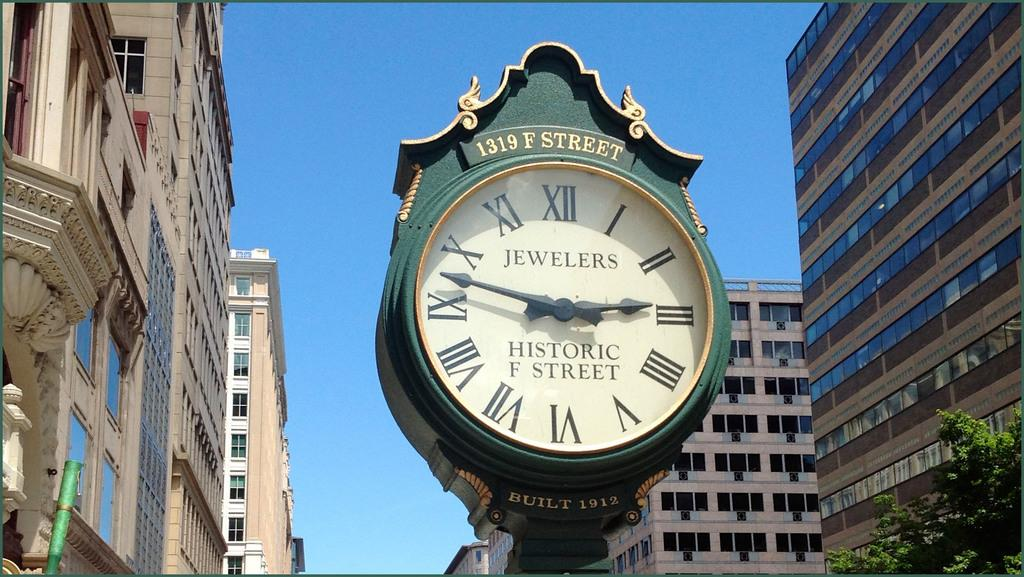<image>
Describe the image concisely. A clock at 1319 F street says "Jewelers" on it. 